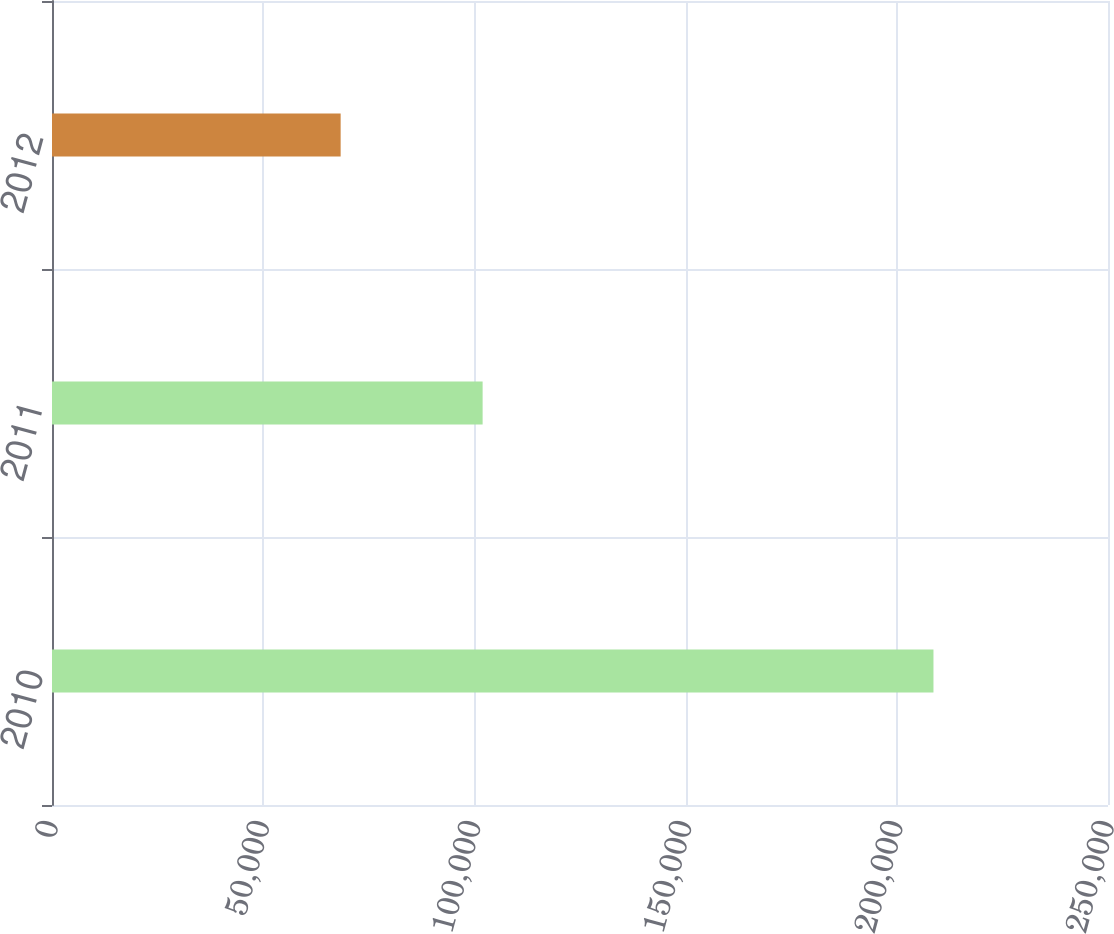Convert chart to OTSL. <chart><loc_0><loc_0><loc_500><loc_500><bar_chart><fcel>2010<fcel>2011<fcel>2012<nl><fcel>208681<fcel>101946<fcel>68335<nl></chart> 